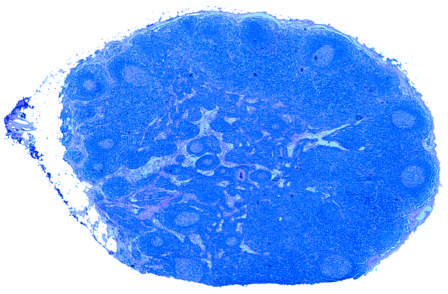re the areas of white chalky deposits illustrated schematically?
Answer the question using a single word or phrase. No 